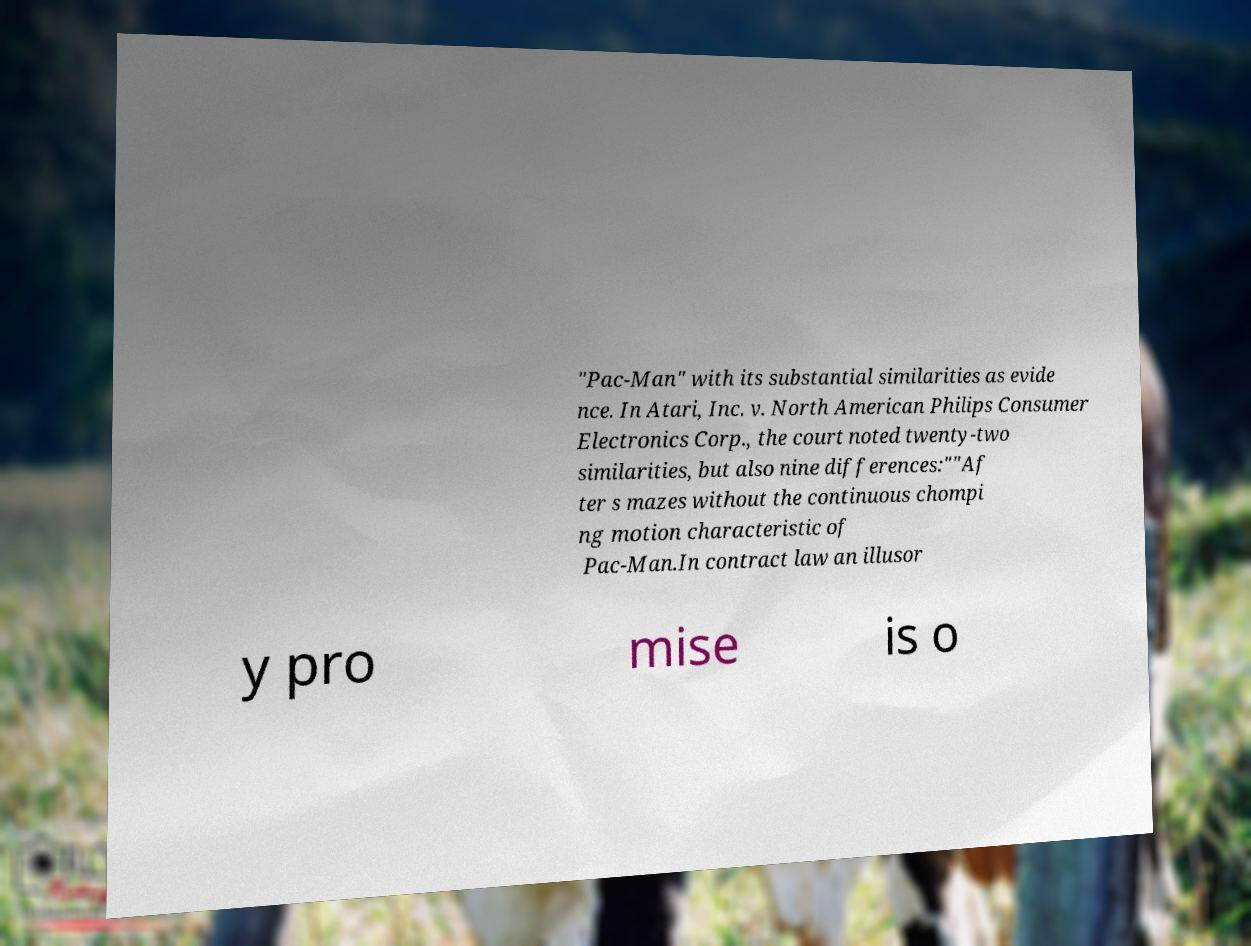What messages or text are displayed in this image? I need them in a readable, typed format. "Pac-Man" with its substantial similarities as evide nce. In Atari, Inc. v. North American Philips Consumer Electronics Corp., the court noted twenty-two similarities, but also nine differences:""Af ter s mazes without the continuous chompi ng motion characteristic of Pac-Man.In contract law an illusor y pro mise is o 